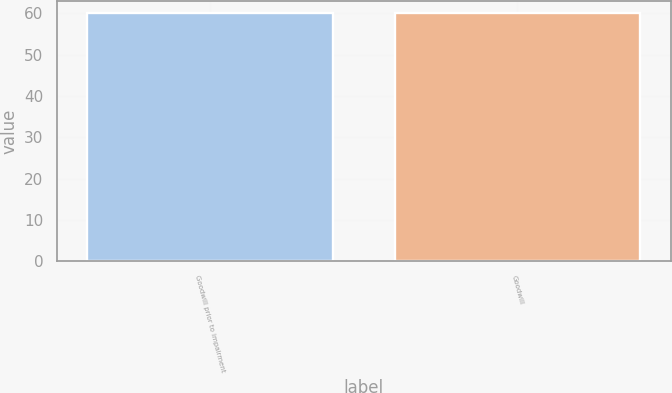Convert chart to OTSL. <chart><loc_0><loc_0><loc_500><loc_500><bar_chart><fcel>Goodwill prior to impairment<fcel>Goodwill<nl><fcel>60<fcel>60.1<nl></chart> 